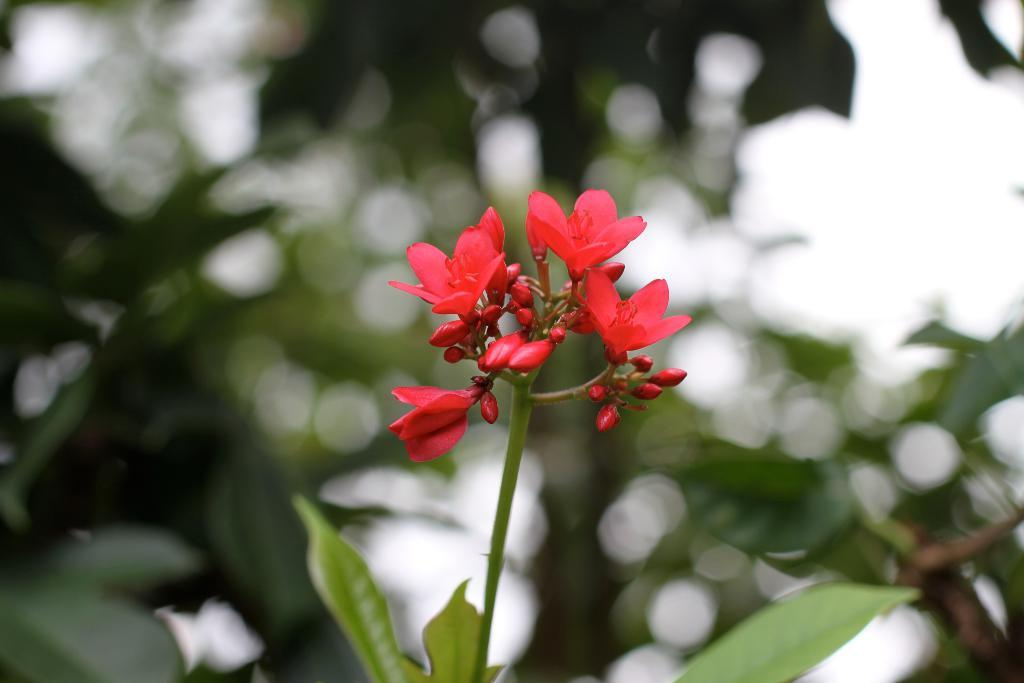What type of flowers can be seen in the image? There are red flowers in the image. What stage of growth are some of the flowers in? There are buds in the image. What parts of the flowers are visible in the image? There are stems and leaves in the image. What time of day is it in the image, based on the hour shown on a nearby clock? There is no clock present in the image, so it is not possible to determine the time of day. 